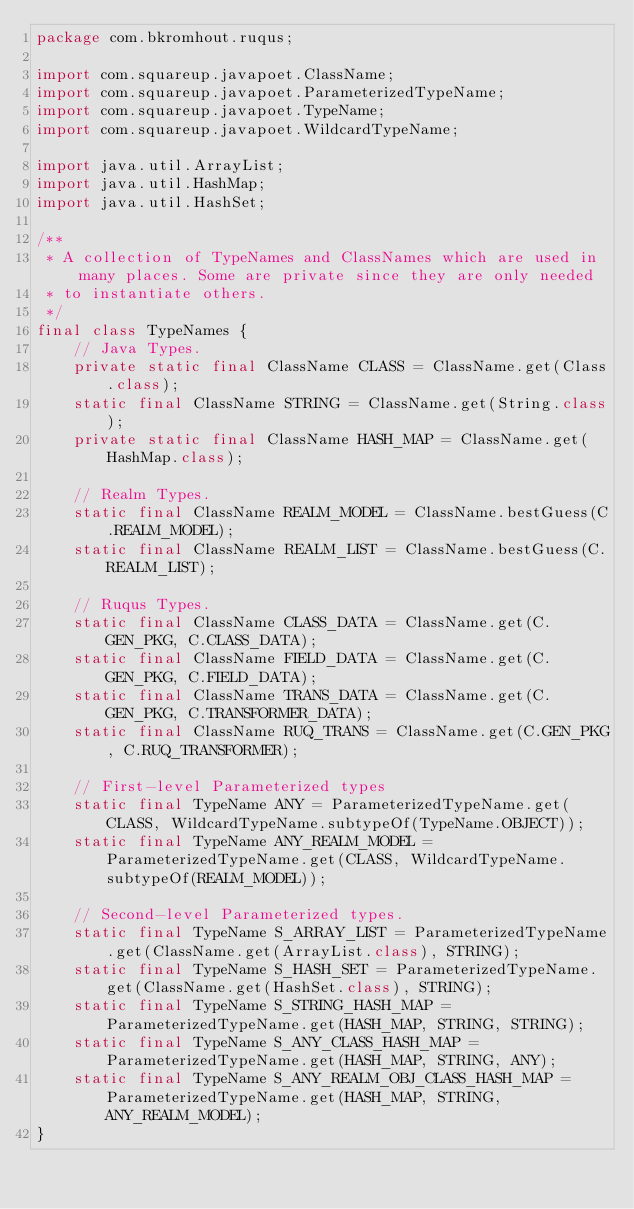Convert code to text. <code><loc_0><loc_0><loc_500><loc_500><_Java_>package com.bkromhout.ruqus;

import com.squareup.javapoet.ClassName;
import com.squareup.javapoet.ParameterizedTypeName;
import com.squareup.javapoet.TypeName;
import com.squareup.javapoet.WildcardTypeName;

import java.util.ArrayList;
import java.util.HashMap;
import java.util.HashSet;

/**
 * A collection of TypeNames and ClassNames which are used in many places. Some are private since they are only needed
 * to instantiate others.
 */
final class TypeNames {
    // Java Types.
    private static final ClassName CLASS = ClassName.get(Class.class);
    static final ClassName STRING = ClassName.get(String.class);
    private static final ClassName HASH_MAP = ClassName.get(HashMap.class);

    // Realm Types.
    static final ClassName REALM_MODEL = ClassName.bestGuess(C.REALM_MODEL);
    static final ClassName REALM_LIST = ClassName.bestGuess(C.REALM_LIST);

    // Ruqus Types.
    static final ClassName CLASS_DATA = ClassName.get(C.GEN_PKG, C.CLASS_DATA);
    static final ClassName FIELD_DATA = ClassName.get(C.GEN_PKG, C.FIELD_DATA);
    static final ClassName TRANS_DATA = ClassName.get(C.GEN_PKG, C.TRANSFORMER_DATA);
    static final ClassName RUQ_TRANS = ClassName.get(C.GEN_PKG, C.RUQ_TRANSFORMER);

    // First-level Parameterized types
    static final TypeName ANY = ParameterizedTypeName.get(CLASS, WildcardTypeName.subtypeOf(TypeName.OBJECT));
    static final TypeName ANY_REALM_MODEL = ParameterizedTypeName.get(CLASS, WildcardTypeName.subtypeOf(REALM_MODEL));

    // Second-level Parameterized types.
    static final TypeName S_ARRAY_LIST = ParameterizedTypeName.get(ClassName.get(ArrayList.class), STRING);
    static final TypeName S_HASH_SET = ParameterizedTypeName.get(ClassName.get(HashSet.class), STRING);
    static final TypeName S_STRING_HASH_MAP = ParameterizedTypeName.get(HASH_MAP, STRING, STRING);
    static final TypeName S_ANY_CLASS_HASH_MAP = ParameterizedTypeName.get(HASH_MAP, STRING, ANY);
    static final TypeName S_ANY_REALM_OBJ_CLASS_HASH_MAP = ParameterizedTypeName.get(HASH_MAP, STRING, ANY_REALM_MODEL);
}
</code> 